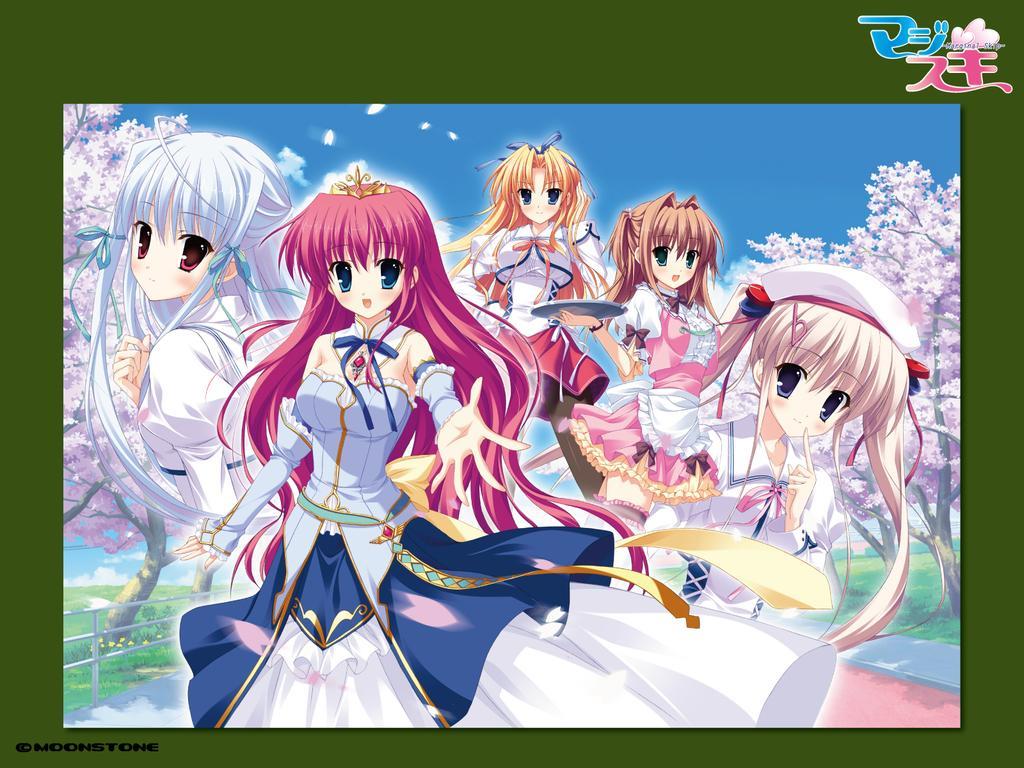Can you describe this image briefly? This is the animated picture. Five persons are standing here. These are the trees. And on the background there is a sky. 